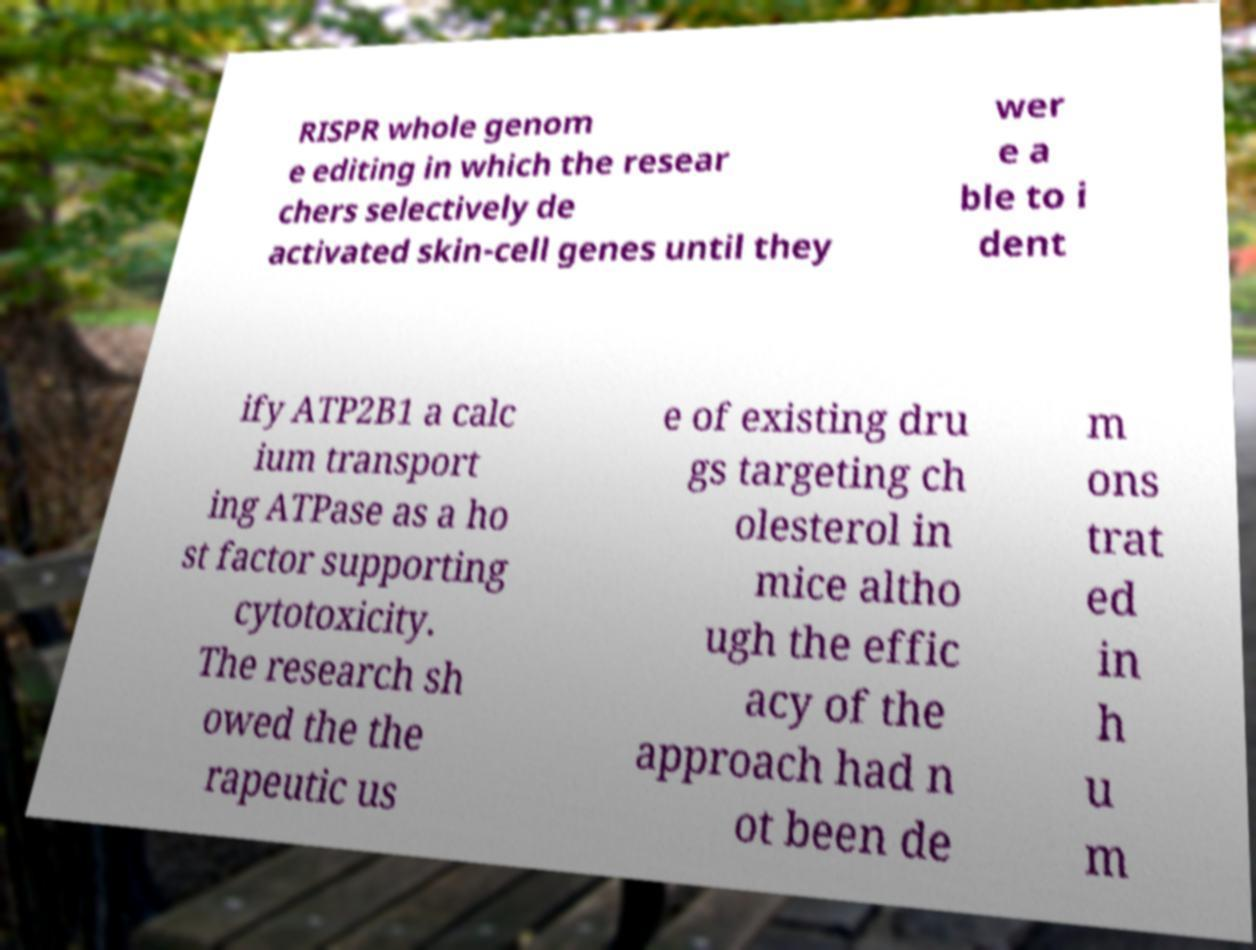There's text embedded in this image that I need extracted. Can you transcribe it verbatim? RISPR whole genom e editing in which the resear chers selectively de activated skin-cell genes until they wer e a ble to i dent ify ATP2B1 a calc ium transport ing ATPase as a ho st factor supporting cytotoxicity. The research sh owed the the rapeutic us e of existing dru gs targeting ch olesterol in mice altho ugh the effic acy of the approach had n ot been de m ons trat ed in h u m 